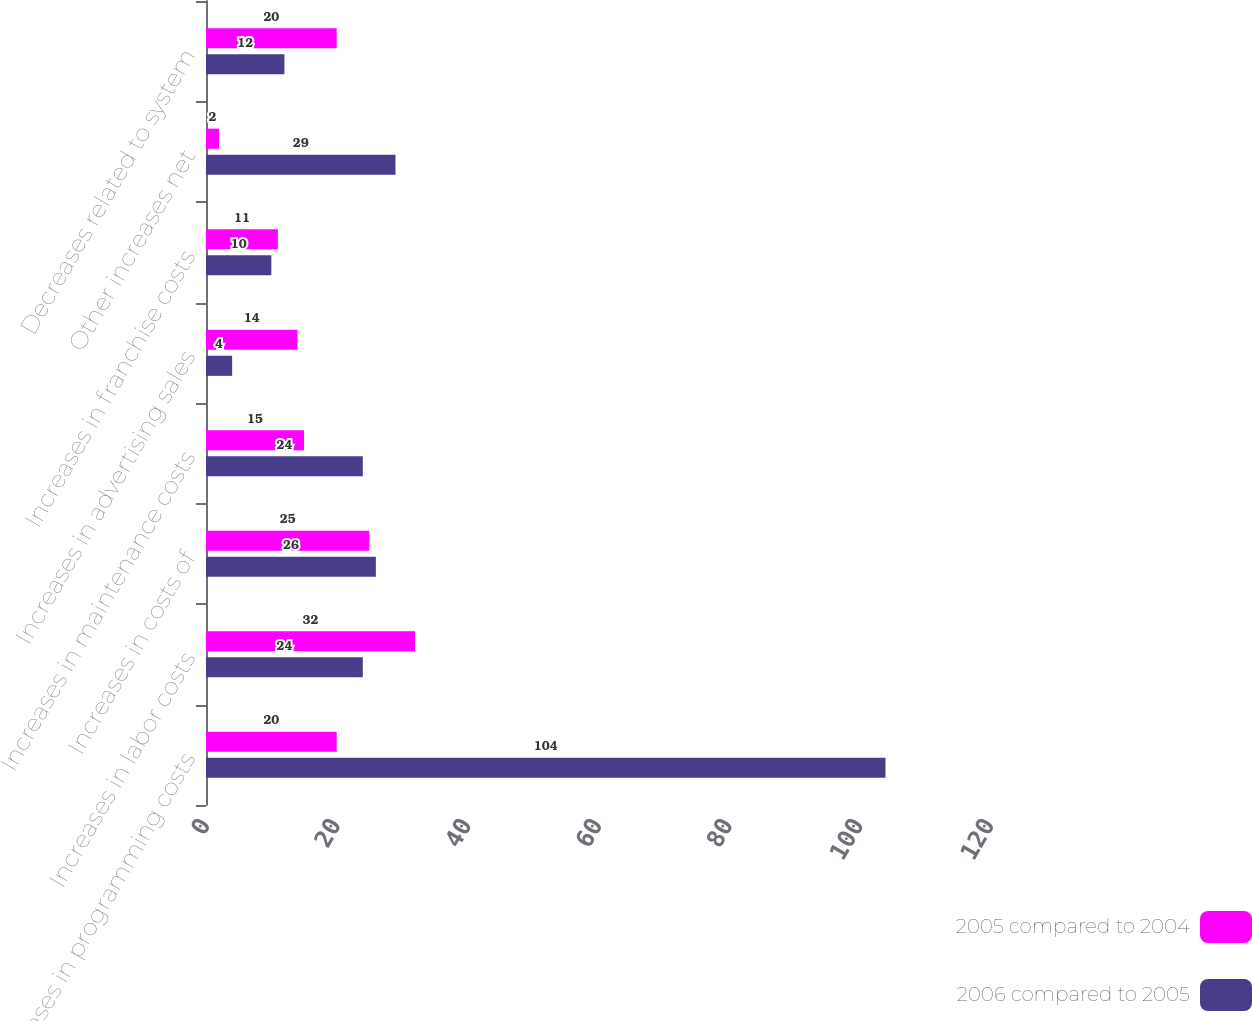<chart> <loc_0><loc_0><loc_500><loc_500><stacked_bar_chart><ecel><fcel>Increases in programming costs<fcel>Increases in labor costs<fcel>Increases in costs of<fcel>Increases in maintenance costs<fcel>Increases in advertising sales<fcel>Increases in franchise costs<fcel>Other increases net<fcel>Decreases related to system<nl><fcel>2005 compared to 2004<fcel>20<fcel>32<fcel>25<fcel>15<fcel>14<fcel>11<fcel>2<fcel>20<nl><fcel>2006 compared to 2005<fcel>104<fcel>24<fcel>26<fcel>24<fcel>4<fcel>10<fcel>29<fcel>12<nl></chart> 